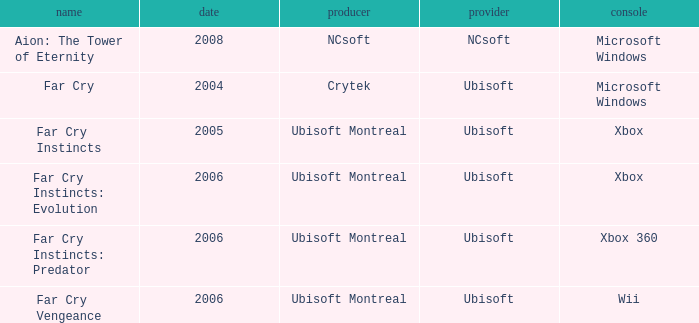Which title has xbox as the platform with a year prior to 2006? Far Cry Instincts. 